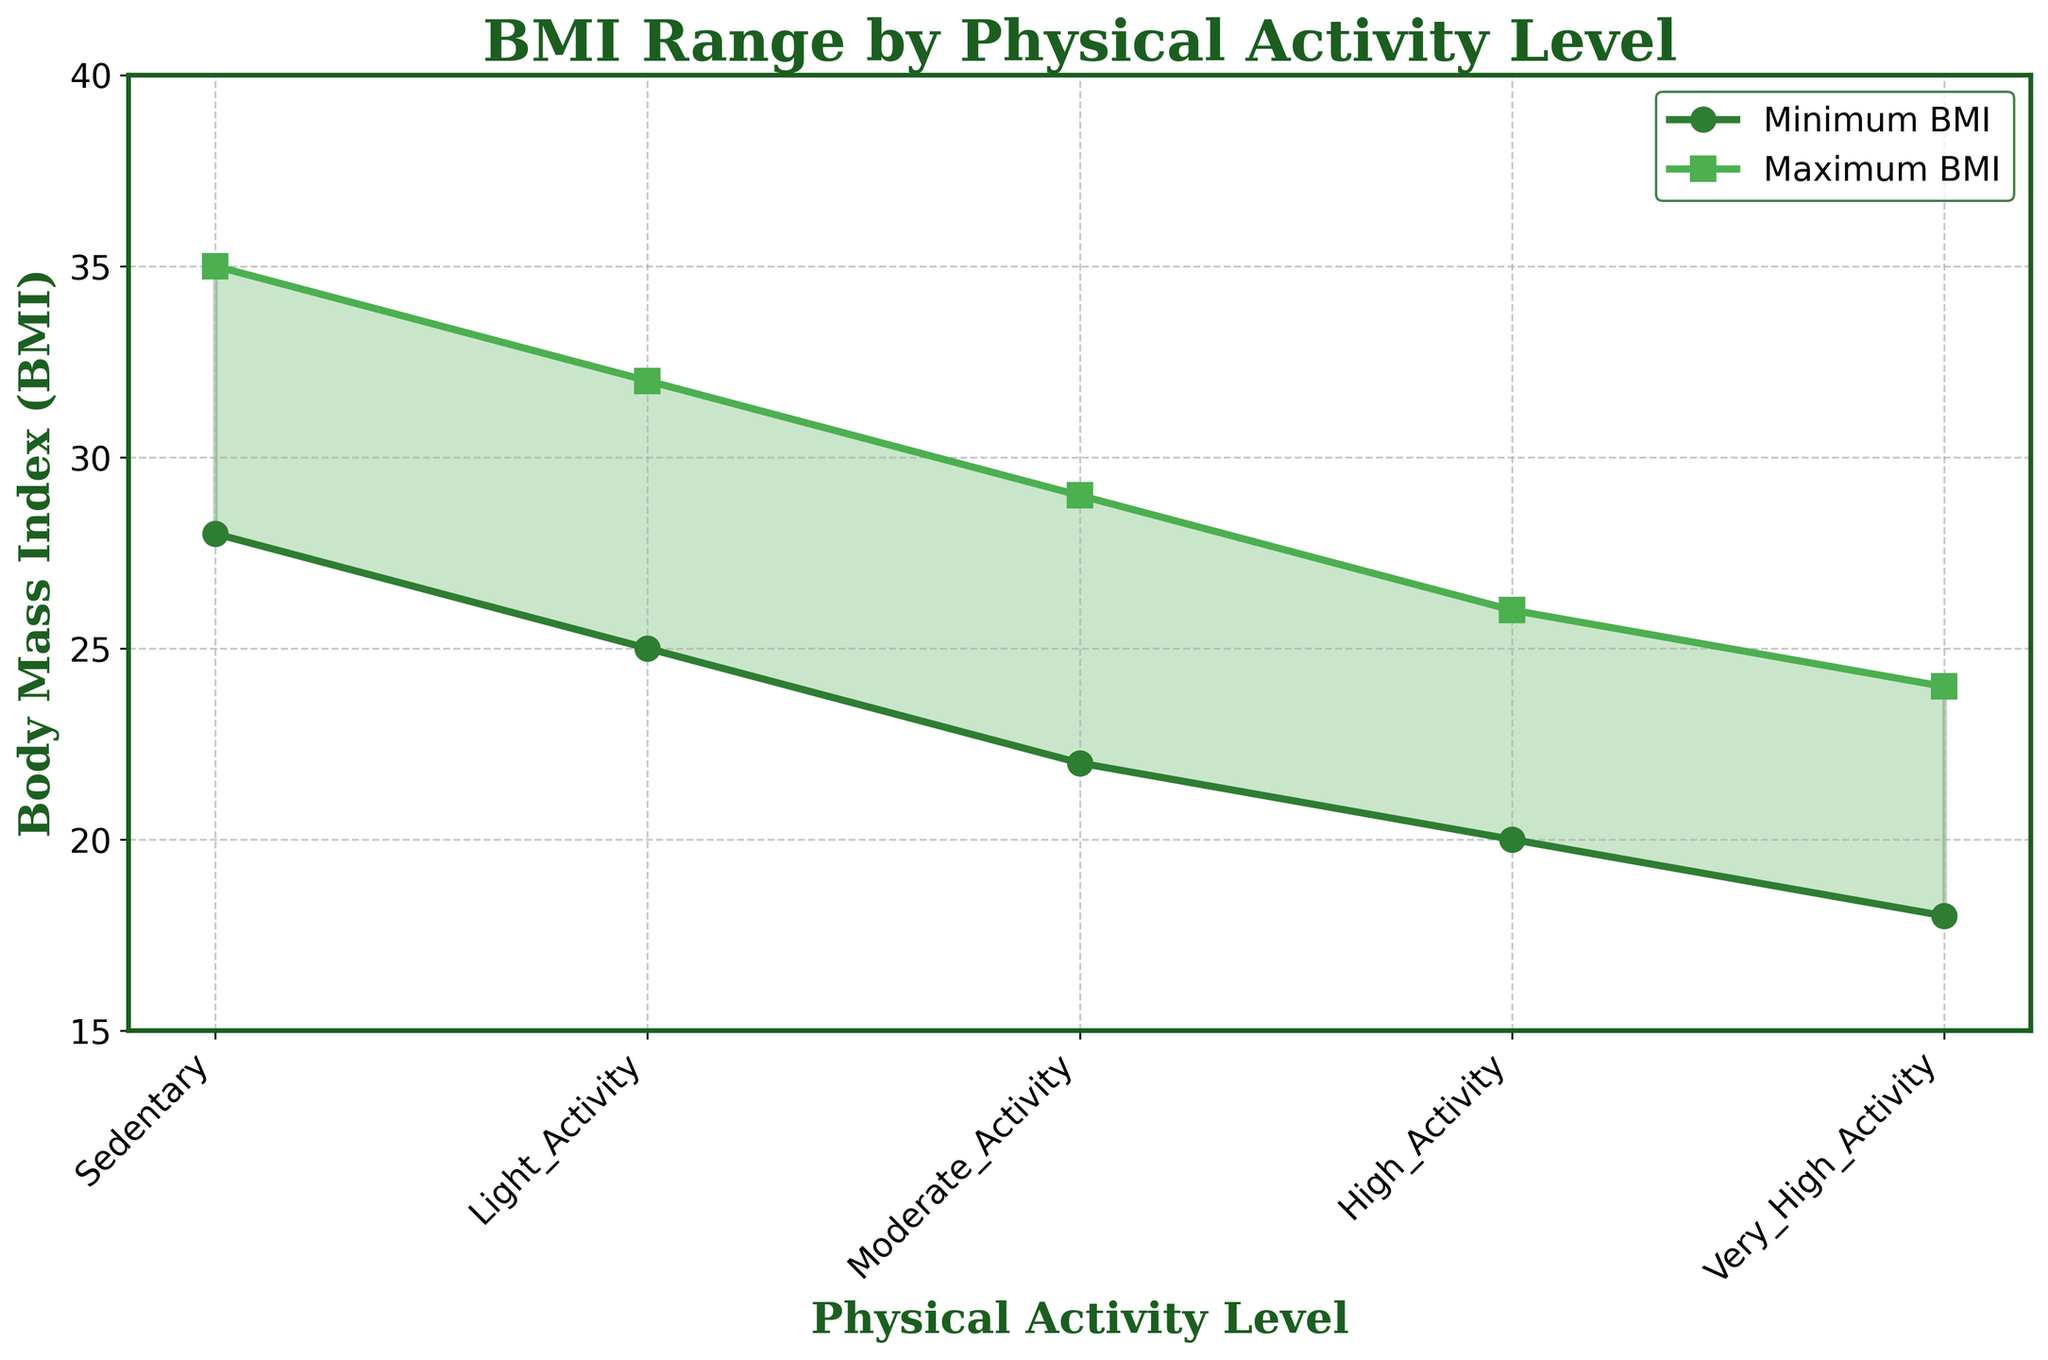What is the title of the figure? The title of the figure is located at the top of the chart. It reads "BMI Range by Physical Activity Level."
Answer: BMI Range by Physical Activity Level How many physical activity levels are depicted in the figure? Look at the x-axis labeled "Physical Activity Level" to count all distinct activity levels. There are five: Sedentary, Light Activity, Moderate Activity, High Activity, and Very High Activity.
Answer: Five Which physical activity level has the highest maximum BMI? To find this, look at the top of the filled area where each activity level is plotted. The Sedentary level has the highest maximum BMI at 35.
Answer: Sedentary Which physical activity level has the lowest minimum BMI? Look at the bottom part of the filled area for each activity level. The Very High Activity level has the lowest minimum BMI at 18.
Answer: Very High Activity What is the BMI range for Moderate Activity? To find the BMI range, subtract the minimum BMI from the maximum BMI for Moderate Activity. Max BMI is 29 and Min BMI is 22. Thus, 29 - 22 = 7.
Answer: 7 Compare the maximum BMI of Light Activity and High Activity. Which one is higher and by how much? The maximum BMI for Light Activity is 32, and for High Activity, it is 26. The difference is calculated as 32 - 26 = 6. So, Light Activity is higher by 6 BMI points.
Answer: Light Activity by 6 How does the BMI range change from Sedentary to Very High Activity? Compare the ranges for Sedentary and Very High Activity. For Sedentary, the range is 35 - 28 = 7. For Very High Activity, the range is 24 - 18 = 6. The range slightly decreases as physical activity increases.
Answer: Decreases slightly What is the overall trend of the minimum and maximum BMI as physical activity level increases? Examine how the plots for minimum and maximum BMI change across increasing activity levels. Both minimum and maximum BMI values tend to decrease as physical activity increases.
Answer: Decreasing trend What is the difference in minimum BMI between Sedentary and High Activity levels? The minimum BMI for Sedentary is 28, while for High Activity, it is 20. Subtracting these gives 28 - 20 = 8.
Answer: 8 At which physical activity level do the minimum and maximum BMI values have the smallest range? Calculate the BMI range for each activity level and find the minimum one. The smallest range is at Very High Activity with 24 - 18 = 6.
Answer: Very High Activity 